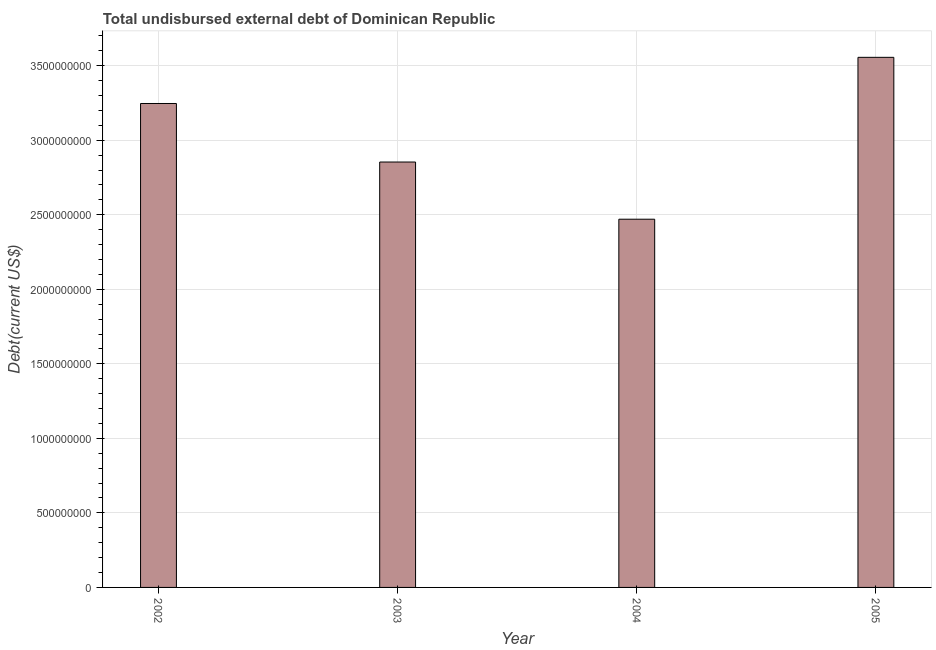What is the title of the graph?
Offer a terse response. Total undisbursed external debt of Dominican Republic. What is the label or title of the X-axis?
Keep it short and to the point. Year. What is the label or title of the Y-axis?
Your response must be concise. Debt(current US$). What is the total debt in 2002?
Make the answer very short. 3.25e+09. Across all years, what is the maximum total debt?
Provide a short and direct response. 3.56e+09. Across all years, what is the minimum total debt?
Provide a succinct answer. 2.47e+09. In which year was the total debt maximum?
Provide a succinct answer. 2005. In which year was the total debt minimum?
Your answer should be compact. 2004. What is the sum of the total debt?
Your answer should be very brief. 1.21e+1. What is the difference between the total debt in 2003 and 2005?
Keep it short and to the point. -7.02e+08. What is the average total debt per year?
Provide a succinct answer. 3.03e+09. What is the median total debt?
Keep it short and to the point. 3.05e+09. Do a majority of the years between 2003 and 2005 (inclusive) have total debt greater than 3400000000 US$?
Your answer should be very brief. No. What is the ratio of the total debt in 2004 to that in 2005?
Your response must be concise. 0.69. What is the difference between the highest and the second highest total debt?
Your response must be concise. 3.10e+08. Is the sum of the total debt in 2002 and 2003 greater than the maximum total debt across all years?
Give a very brief answer. Yes. What is the difference between the highest and the lowest total debt?
Provide a short and direct response. 1.09e+09. What is the Debt(current US$) of 2002?
Offer a terse response. 3.25e+09. What is the Debt(current US$) of 2003?
Make the answer very short. 2.85e+09. What is the Debt(current US$) of 2004?
Give a very brief answer. 2.47e+09. What is the Debt(current US$) of 2005?
Offer a very short reply. 3.56e+09. What is the difference between the Debt(current US$) in 2002 and 2003?
Make the answer very short. 3.93e+08. What is the difference between the Debt(current US$) in 2002 and 2004?
Offer a very short reply. 7.76e+08. What is the difference between the Debt(current US$) in 2002 and 2005?
Provide a succinct answer. -3.10e+08. What is the difference between the Debt(current US$) in 2003 and 2004?
Provide a succinct answer. 3.84e+08. What is the difference between the Debt(current US$) in 2003 and 2005?
Provide a short and direct response. -7.02e+08. What is the difference between the Debt(current US$) in 2004 and 2005?
Give a very brief answer. -1.09e+09. What is the ratio of the Debt(current US$) in 2002 to that in 2003?
Your response must be concise. 1.14. What is the ratio of the Debt(current US$) in 2002 to that in 2004?
Your answer should be very brief. 1.31. What is the ratio of the Debt(current US$) in 2003 to that in 2004?
Ensure brevity in your answer.  1.16. What is the ratio of the Debt(current US$) in 2003 to that in 2005?
Provide a succinct answer. 0.8. What is the ratio of the Debt(current US$) in 2004 to that in 2005?
Offer a terse response. 0.69. 